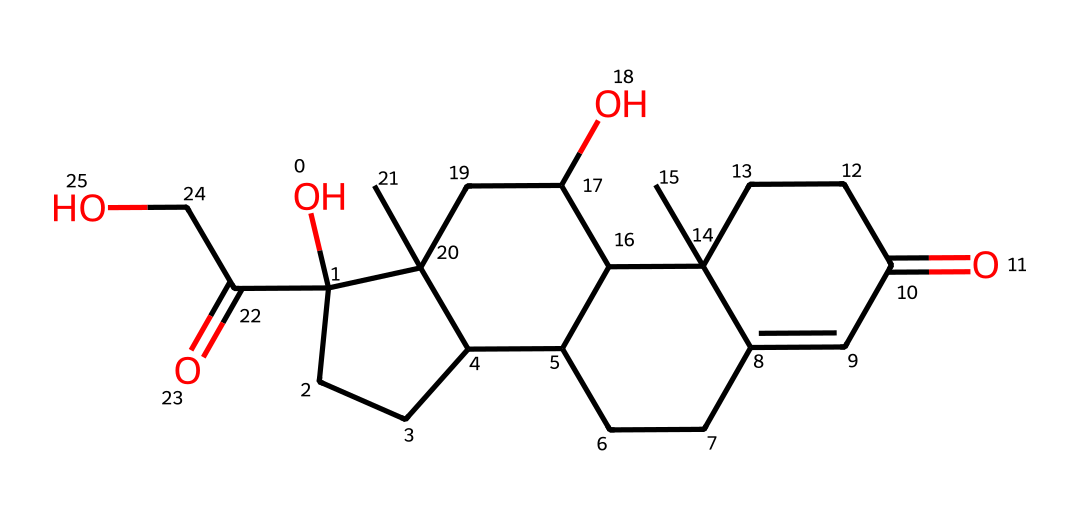What is the molecular formula of cortisol? The molecular formula can be derived by identifying the atoms present in the SMILES representation. The structure contains 21 carbon atoms (C), 30 hydrogen atoms (H), and 5 oxygen atoms (O). Therefore, the molecular formula is C21H30O5.
Answer: C21H30O5 How many rings are present in the cortisol structure? By analyzing the SMILES notation, one can observe that there are four distinct rings present in the structure of cortisol, which is characteristic of steroid hormones.
Answer: four What type of hormone is cortisol classified as? Cortisol belongs to the class of hormones known as glucocorticoids. This classification is based on its function in glucose metabolism and its involvement in stress responses.
Answer: glucocorticoid Which functional groups are indicated in the cortisol structure? Upon inspecting the SMILES, one can identify hydroxyl groups (-OH) and carbonyl groups (C=O) as the significant functional groups present in cortisol, both of which play essential roles in its biochemical activity.
Answer: hydroxyl and carbonyl How does the number of carbon atoms relate to cortisol's classification? The presence of 21 carbon atoms is typical for steroid hormones. Steroids generally contain a specific number of carbons in their structure, and cortisol's carbon count aligns with this typical structure, confirming its classification as a steroid hormone.
Answer: 21 What role does cortisol play in the human body? Cortisol is known as the stress hormone, primarily regulating metabolism, immune response, and the body's response to stress. Its crucial functions are related to energy release and maintaining homeostasis during stressful situations.
Answer: stress hormone 